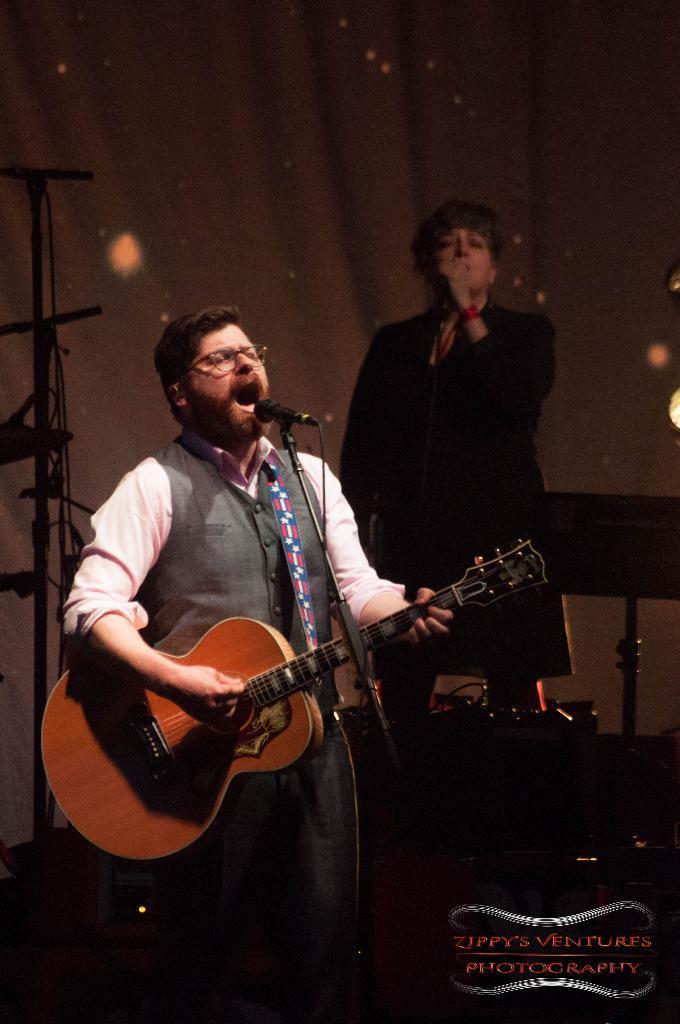Could you give a brief overview of what you see in this image? In this picture we can see a man playing a guitar in front of a microphone and he is also singing, in the background we can see a woman holding a microphone and also we can see cloth. 